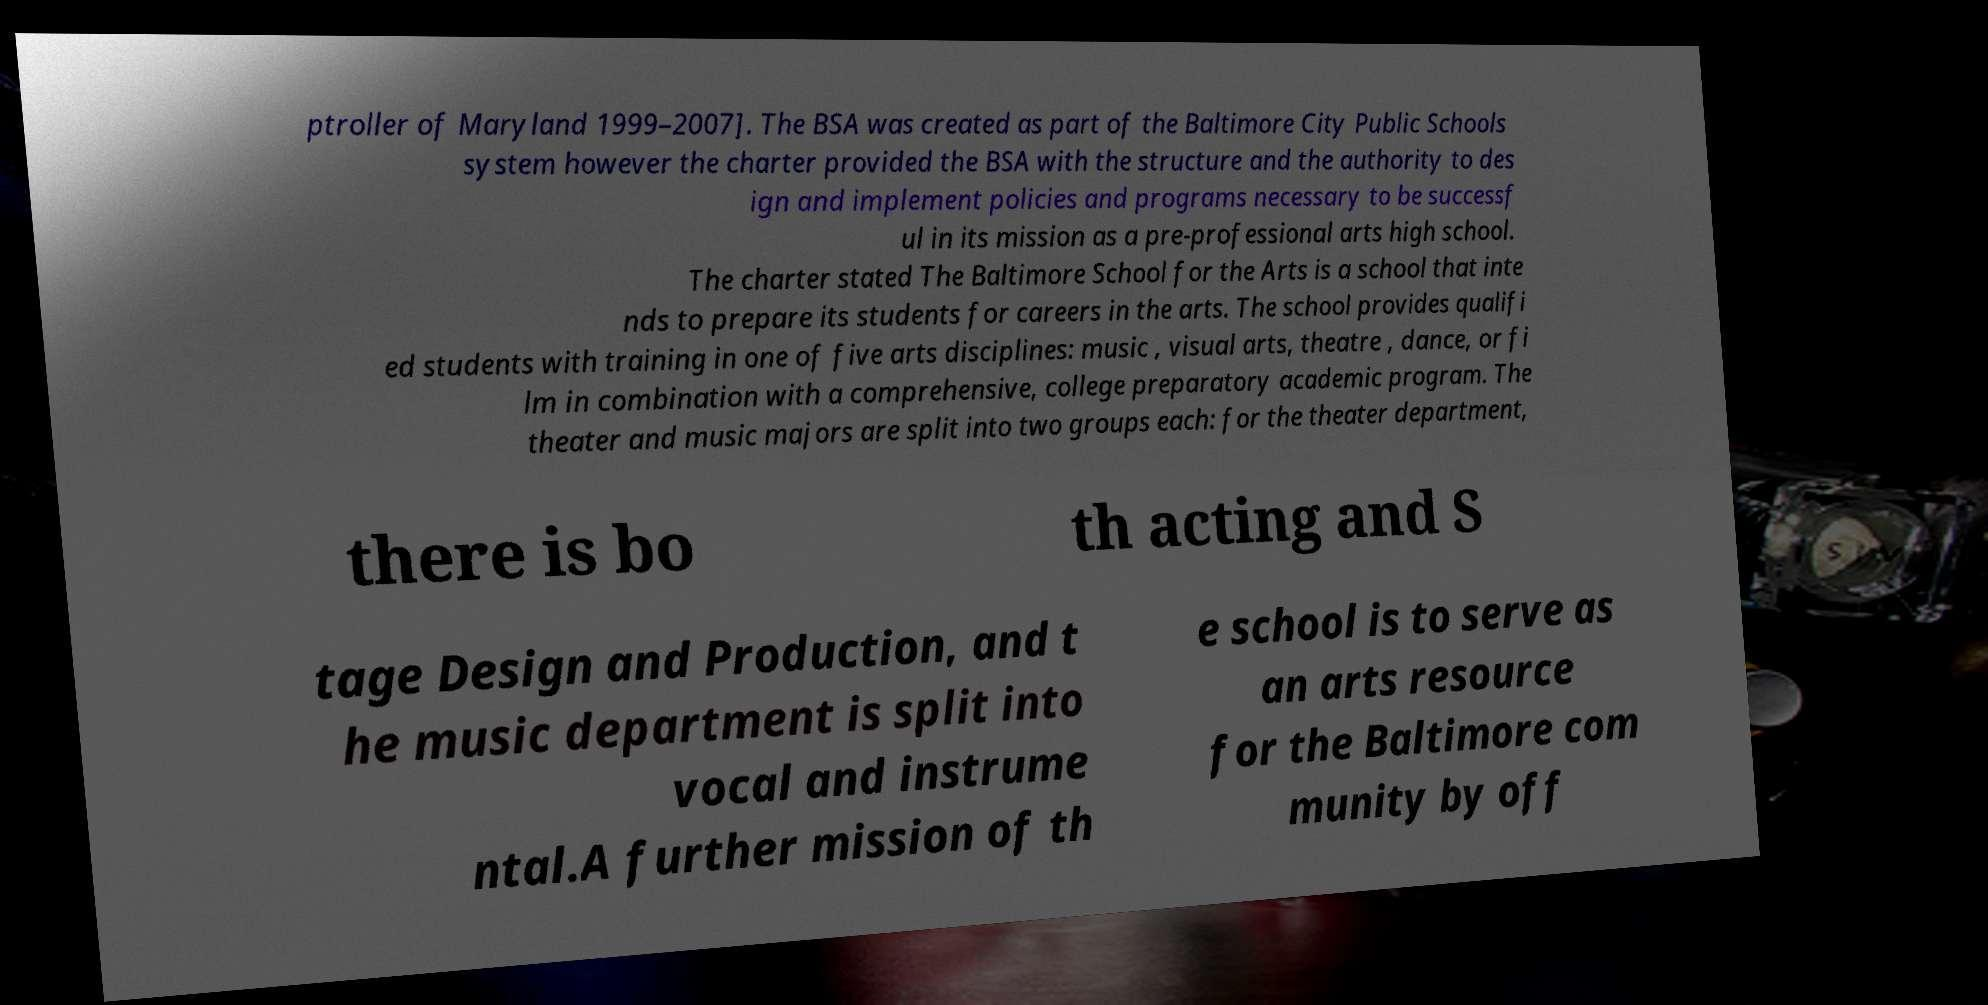Could you assist in decoding the text presented in this image and type it out clearly? ptroller of Maryland 1999–2007]. The BSA was created as part of the Baltimore City Public Schools system however the charter provided the BSA with the structure and the authority to des ign and implement policies and programs necessary to be successf ul in its mission as a pre-professional arts high school. The charter stated The Baltimore School for the Arts is a school that inte nds to prepare its students for careers in the arts. The school provides qualifi ed students with training in one of five arts disciplines: music , visual arts, theatre , dance, or fi lm in combination with a comprehensive, college preparatory academic program. The theater and music majors are split into two groups each: for the theater department, there is bo th acting and S tage Design and Production, and t he music department is split into vocal and instrume ntal.A further mission of th e school is to serve as an arts resource for the Baltimore com munity by off 